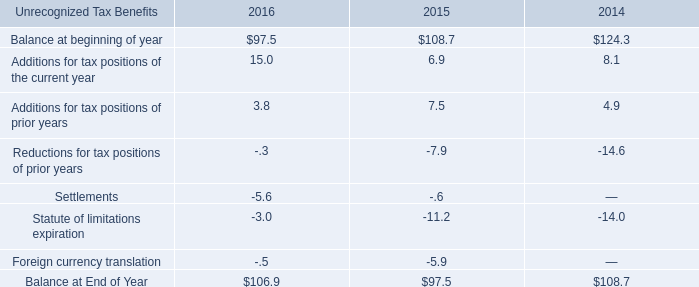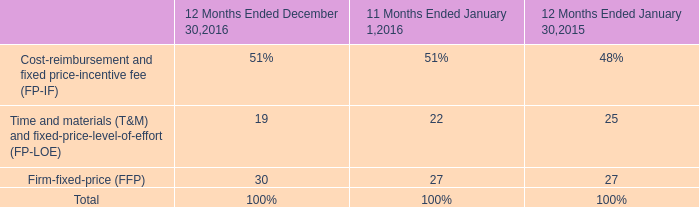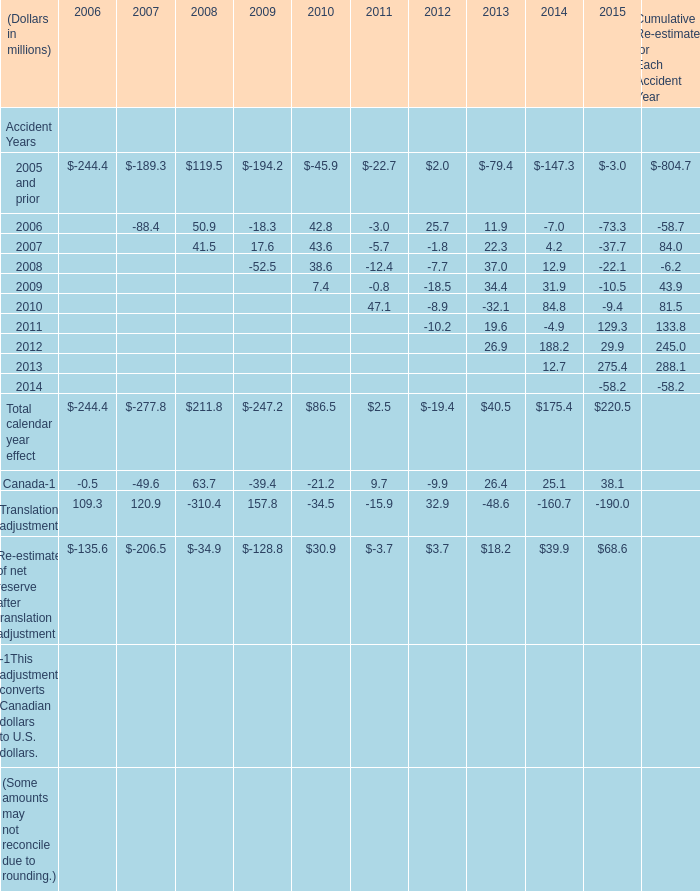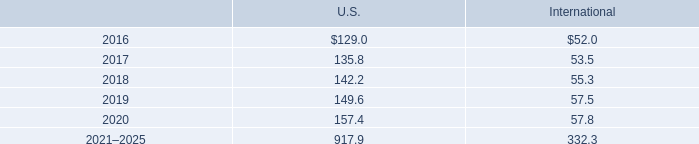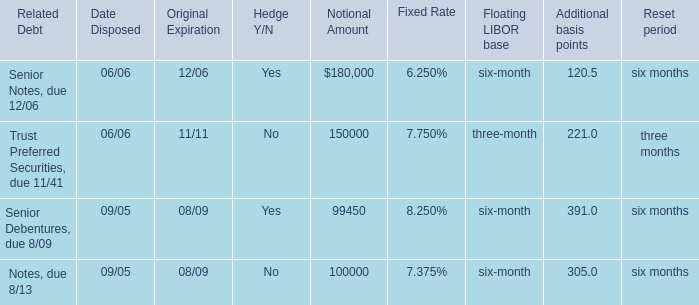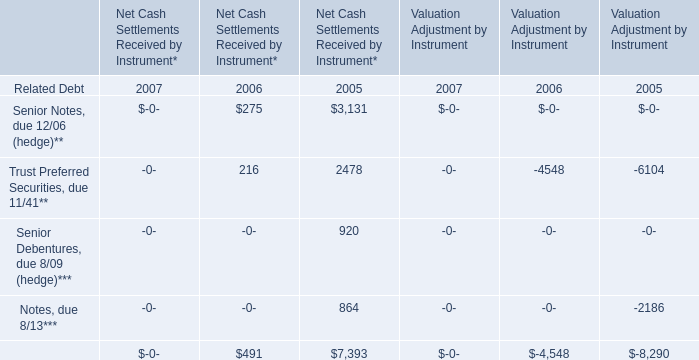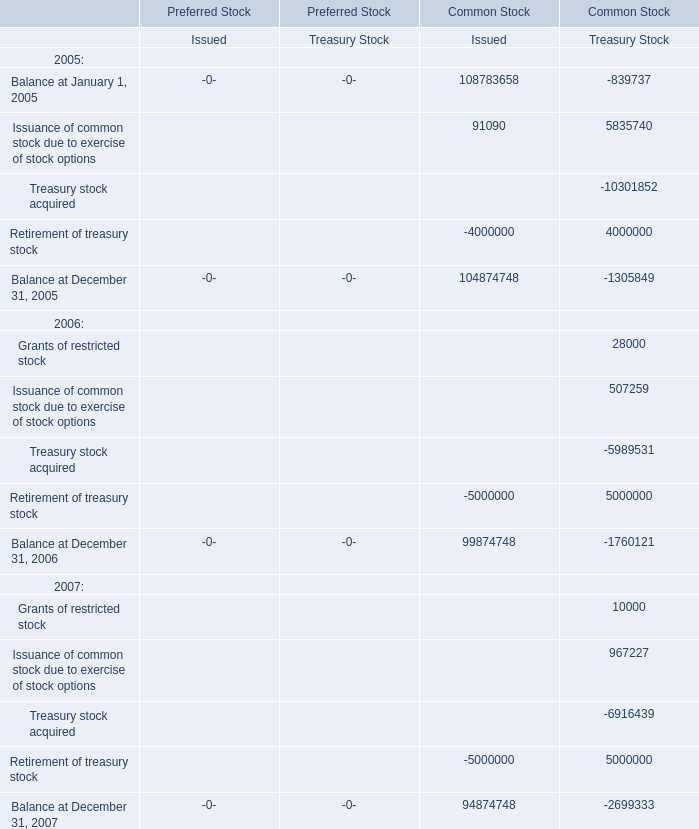what is the increase observed in the accrued balance for interest and penalties during 2015 and 2016? 
Computations: ((9.8 / 7.5) - 1)
Answer: 0.30667. 